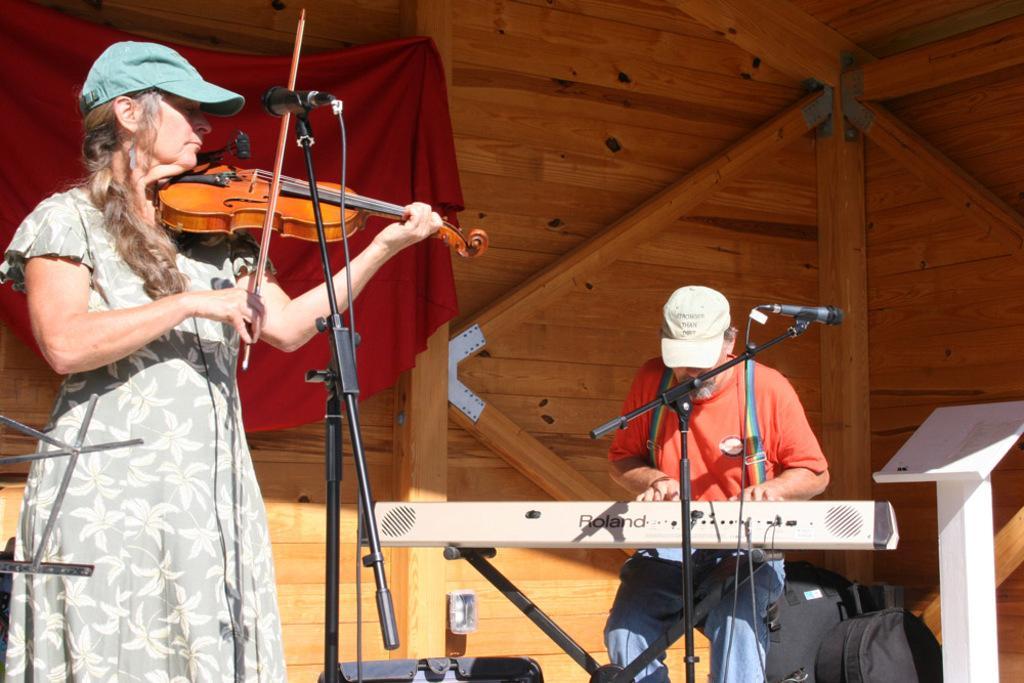Describe this image in one or two sentences. There is a woman who is playing a guitar. This is mike. Here we can see a man who is playing some musical instrument. This is bag. On the background there is a wall and this is cloth. 